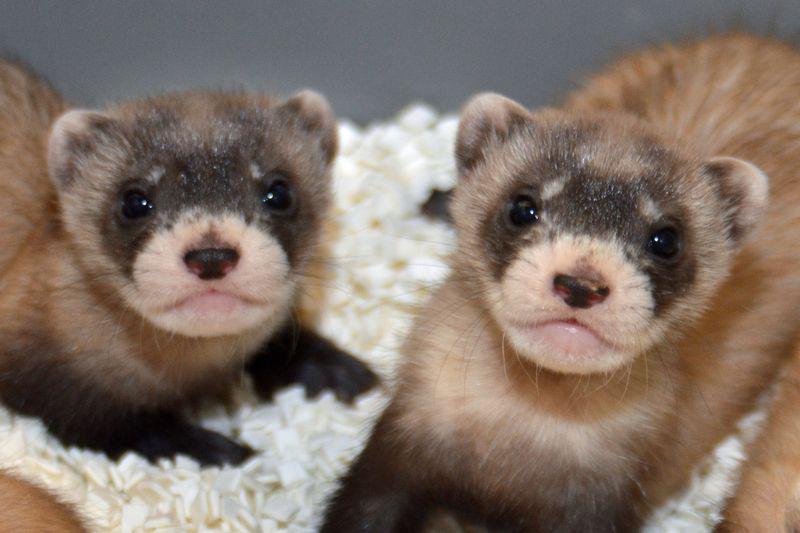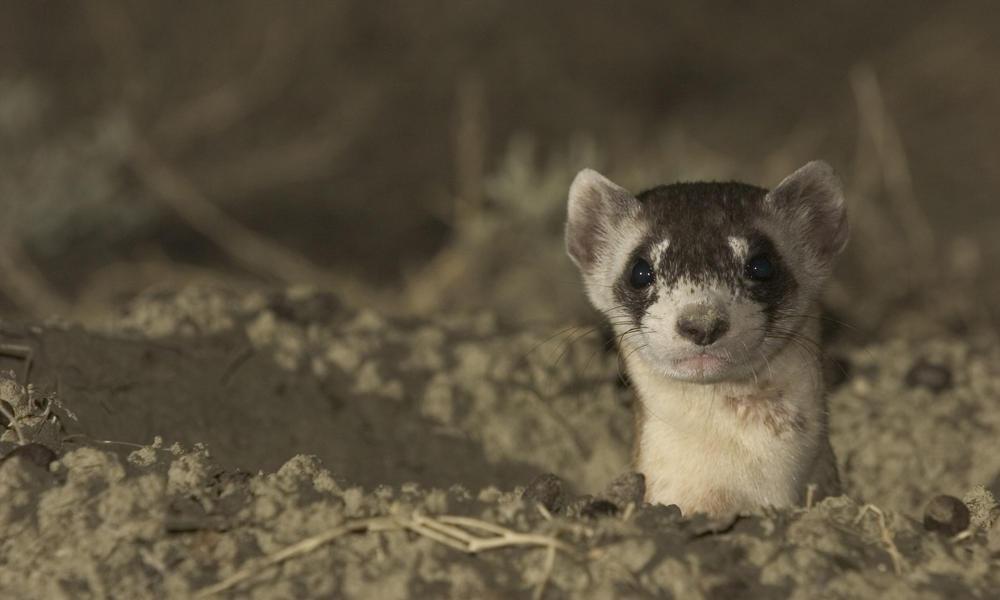The first image is the image on the left, the second image is the image on the right. Evaluate the accuracy of this statement regarding the images: "There are exactly five ferrets in the left image.". Is it true? Answer yes or no. No. The first image is the image on the left, the second image is the image on the right. For the images displayed, is the sentence "There are three ferrets" factually correct? Answer yes or no. Yes. 